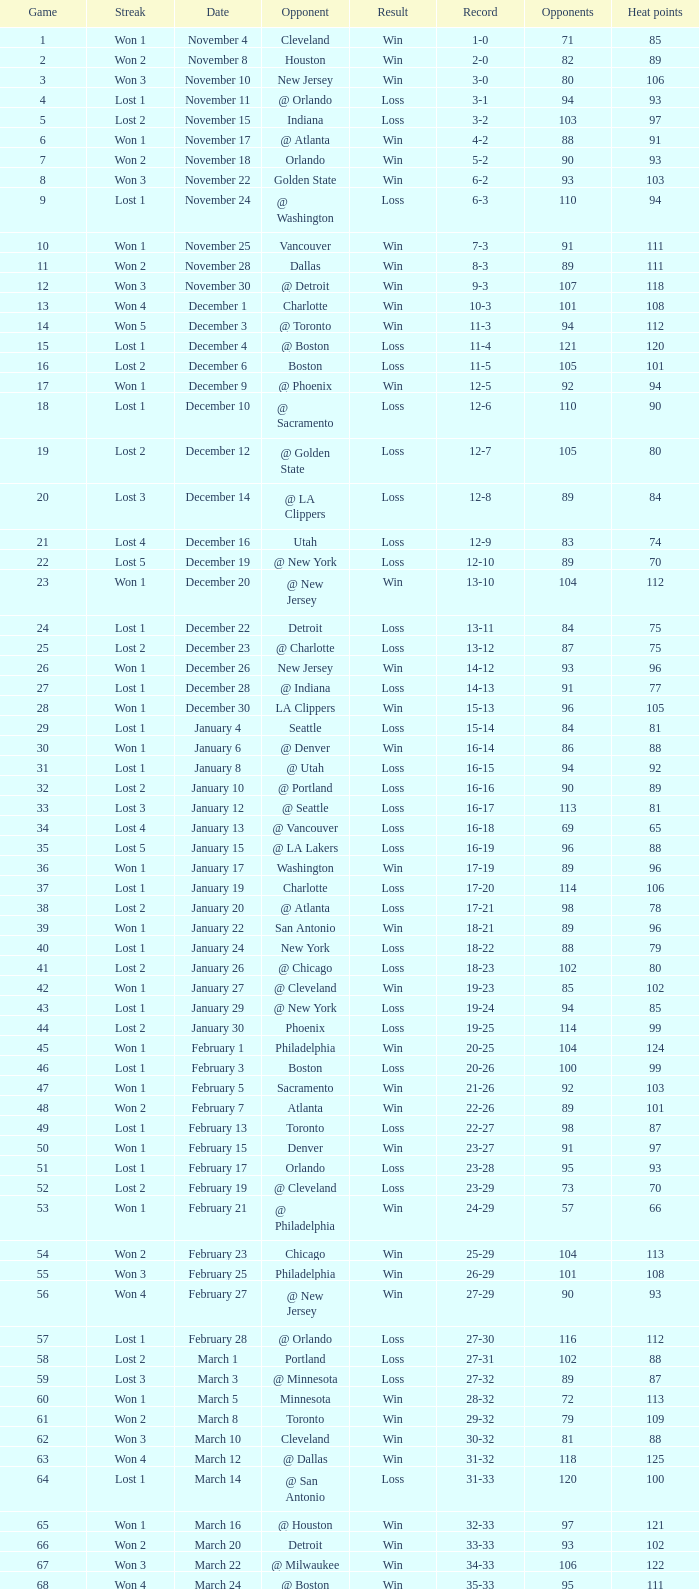What is Heat Points, when Game is less than 80, and when Date is "April 26 (First Round)"? 85.0. 